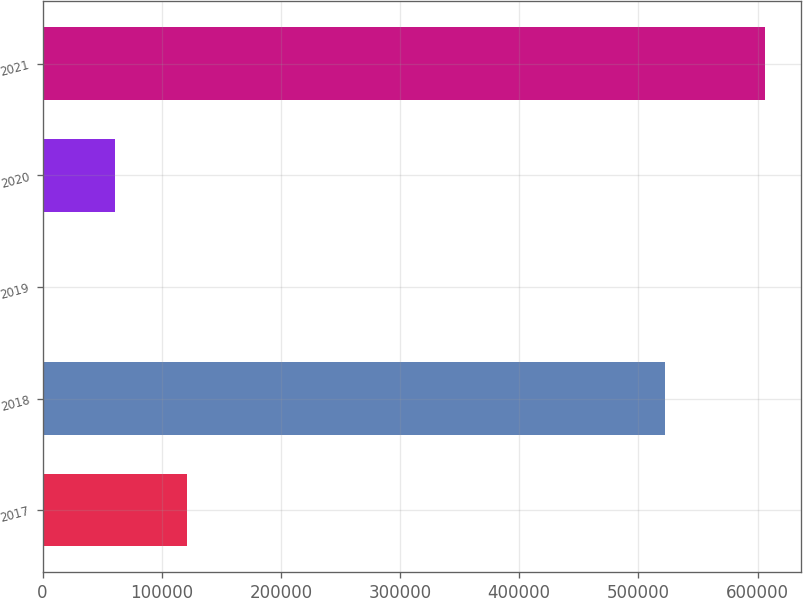Convert chart. <chart><loc_0><loc_0><loc_500><loc_500><bar_chart><fcel>2017<fcel>2018<fcel>2019<fcel>2020<fcel>2021<nl><fcel>121224<fcel>522531<fcel>23<fcel>60623.3<fcel>606026<nl></chart> 